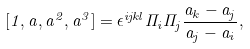Convert formula to latex. <formula><loc_0><loc_0><loc_500><loc_500>[ 1 , a , a ^ { 2 } , a ^ { 3 } ] = \epsilon ^ { i j k l } \Pi _ { i } \Pi _ { j } \frac { a _ { k } - a _ { j } } { a _ { j } - a _ { i } } ,</formula> 